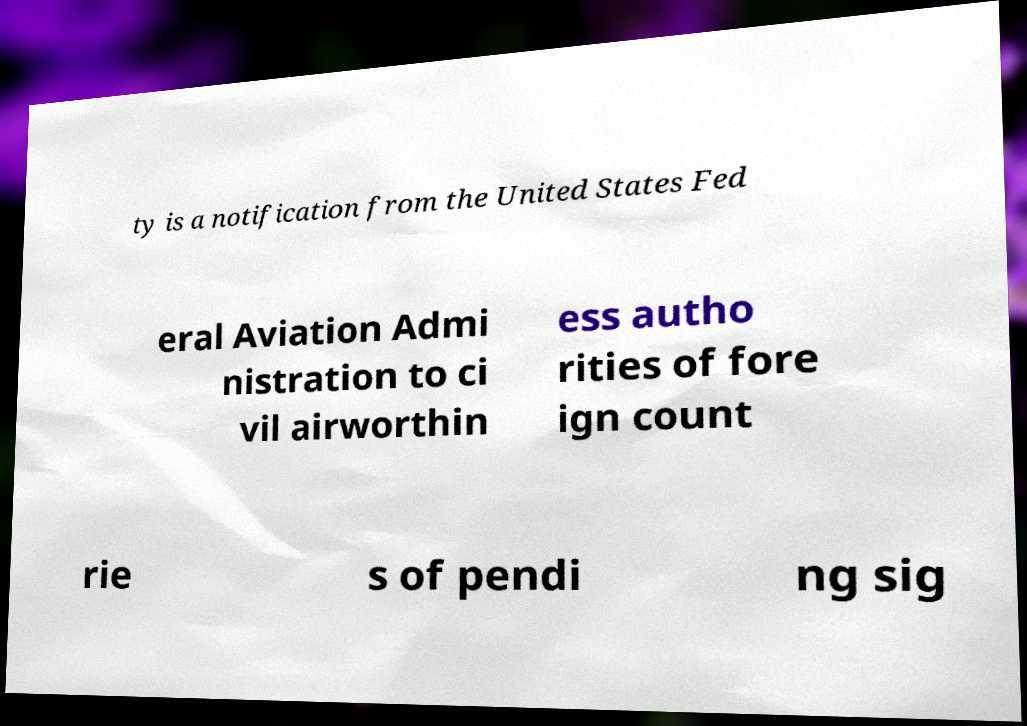Can you accurately transcribe the text from the provided image for me? ty is a notification from the United States Fed eral Aviation Admi nistration to ci vil airworthin ess autho rities of fore ign count rie s of pendi ng sig 